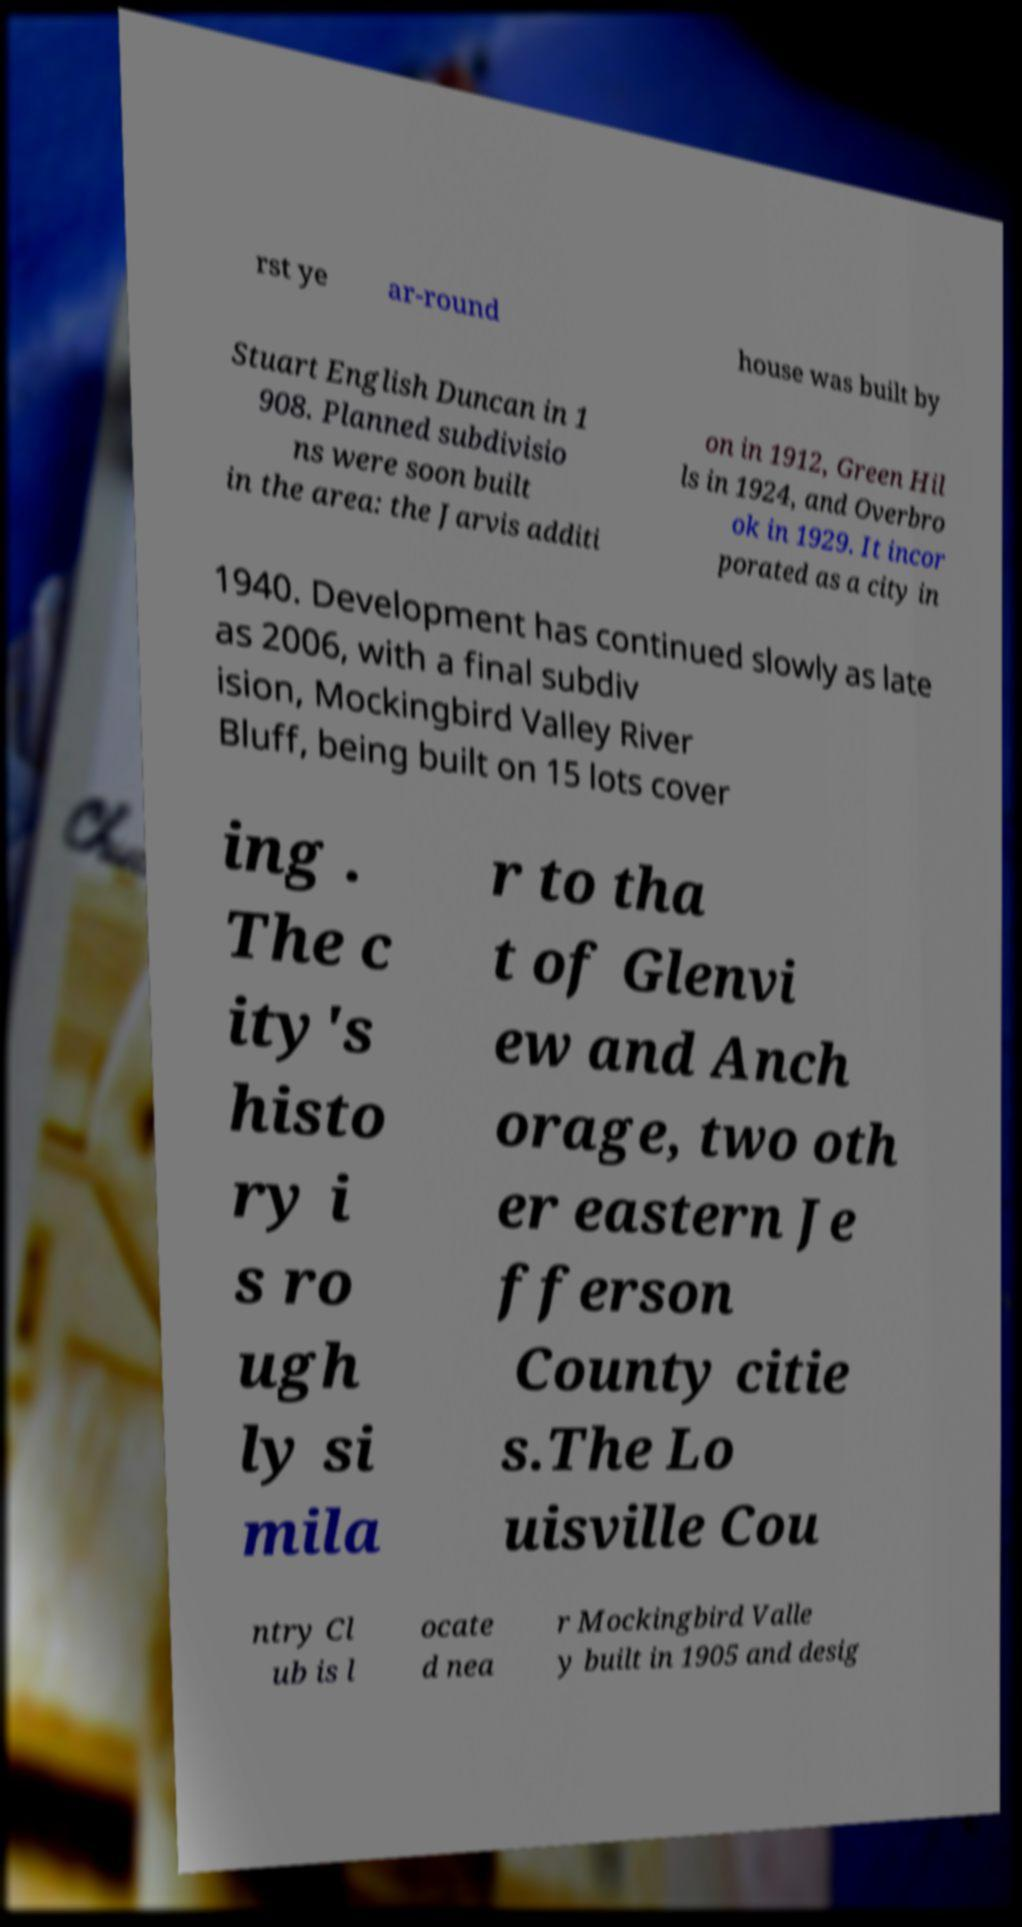What messages or text are displayed in this image? I need them in a readable, typed format. rst ye ar-round house was built by Stuart English Duncan in 1 908. Planned subdivisio ns were soon built in the area: the Jarvis additi on in 1912, Green Hil ls in 1924, and Overbro ok in 1929. It incor porated as a city in 1940. Development has continued slowly as late as 2006, with a final subdiv ision, Mockingbird Valley River Bluff, being built on 15 lots cover ing . The c ity's histo ry i s ro ugh ly si mila r to tha t of Glenvi ew and Anch orage, two oth er eastern Je fferson County citie s.The Lo uisville Cou ntry Cl ub is l ocate d nea r Mockingbird Valle y built in 1905 and desig 